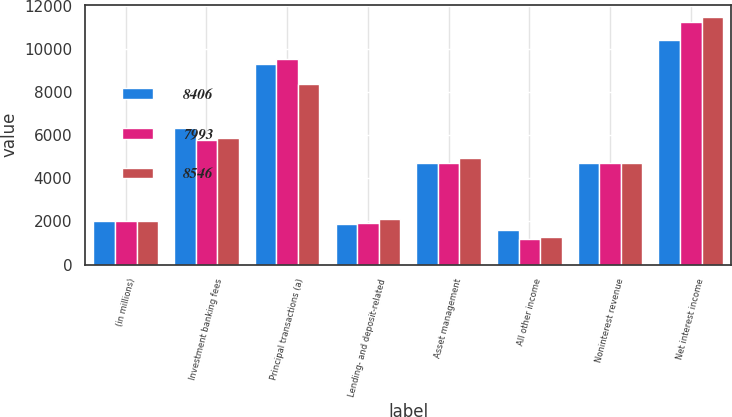Convert chart. <chart><loc_0><loc_0><loc_500><loc_500><stacked_bar_chart><ecel><fcel>(in millions)<fcel>Investment banking fees<fcel>Principal transactions (a)<fcel>Lending- and deposit-related<fcel>Asset management<fcel>All other income<fcel>Noninterest revenue<fcel>Net interest income<nl><fcel>8406<fcel>2013<fcel>6331<fcel>9289<fcel>1884<fcel>4713<fcel>1593<fcel>4713<fcel>10415<nl><fcel>7993<fcel>2012<fcel>5769<fcel>9510<fcel>1948<fcel>4693<fcel>1184<fcel>4713<fcel>11222<nl><fcel>8546<fcel>2011<fcel>5859<fcel>8347<fcel>2098<fcel>4955<fcel>1264<fcel>4713<fcel>11461<nl></chart> 